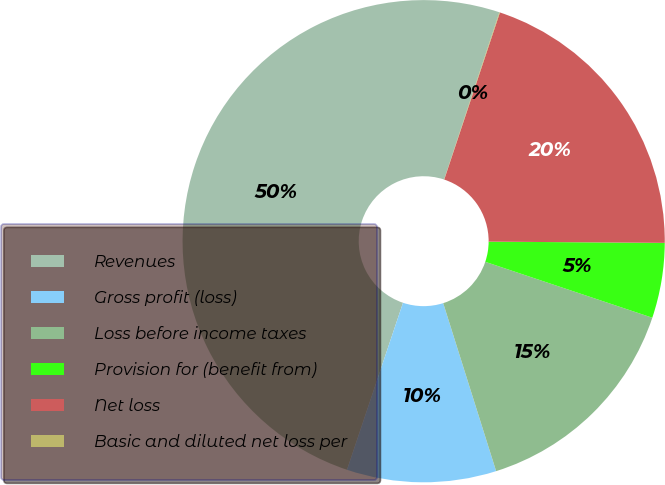<chart> <loc_0><loc_0><loc_500><loc_500><pie_chart><fcel>Revenues<fcel>Gross profit (loss)<fcel>Loss before income taxes<fcel>Provision for (benefit from)<fcel>Net loss<fcel>Basic and diluted net loss per<nl><fcel>49.93%<fcel>10.01%<fcel>15.0%<fcel>5.03%<fcel>19.99%<fcel>0.04%<nl></chart> 